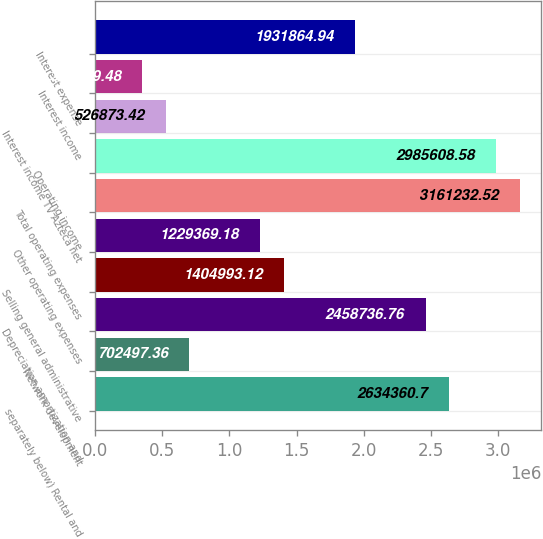Convert chart to OTSL. <chart><loc_0><loc_0><loc_500><loc_500><bar_chart><fcel>separately below) Rental and<fcel>Network development<fcel>Depreciation amortization and<fcel>Selling general administrative<fcel>Other operating expenses<fcel>Total operating expenses<fcel>Operating income<fcel>Interest income TV Azteca net<fcel>Interest income<fcel>Interest expense<nl><fcel>2.63436e+06<fcel>702497<fcel>2.45874e+06<fcel>1.40499e+06<fcel>1.22937e+06<fcel>3.16123e+06<fcel>2.98561e+06<fcel>526873<fcel>351249<fcel>1.93186e+06<nl></chart> 